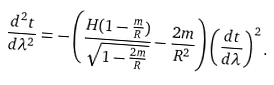Convert formula to latex. <formula><loc_0><loc_0><loc_500><loc_500>\frac { d ^ { 2 } t } { d \lambda ^ { 2 } } = - \left ( \frac { H ( 1 - \frac { m } { R } ) } { \sqrt { 1 - \frac { 2 m } { R } } } - \frac { 2 m } { R ^ { 2 } } \right ) \left ( \frac { d t } { d \lambda } \right ) ^ { 2 } .</formula> 